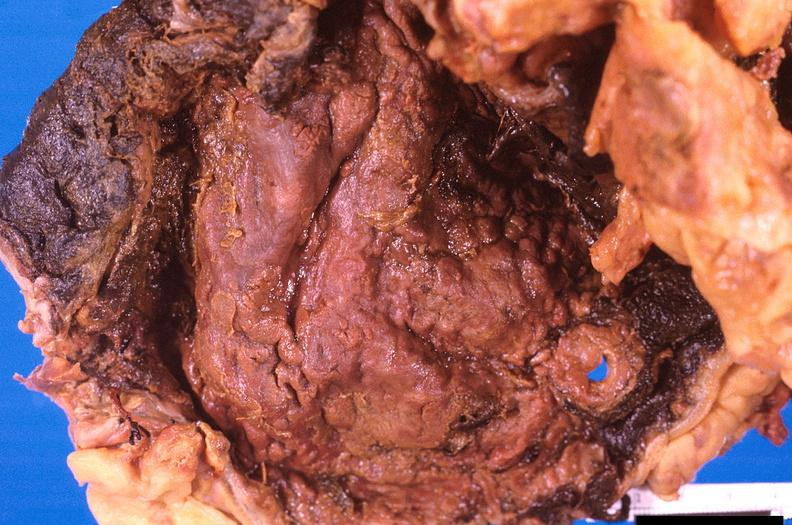what is stomach , necrotizing esophagitis and gastritis , sulfuric acid ingested?
Answer the question using a single word or phrase. As suicide attempt 